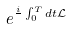Convert formula to latex. <formula><loc_0><loc_0><loc_500><loc_500>e ^ { \frac { i } { } \int _ { 0 } ^ { T } d t \mathcal { L } }</formula> 